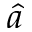<formula> <loc_0><loc_0><loc_500><loc_500>\hat { a }</formula> 